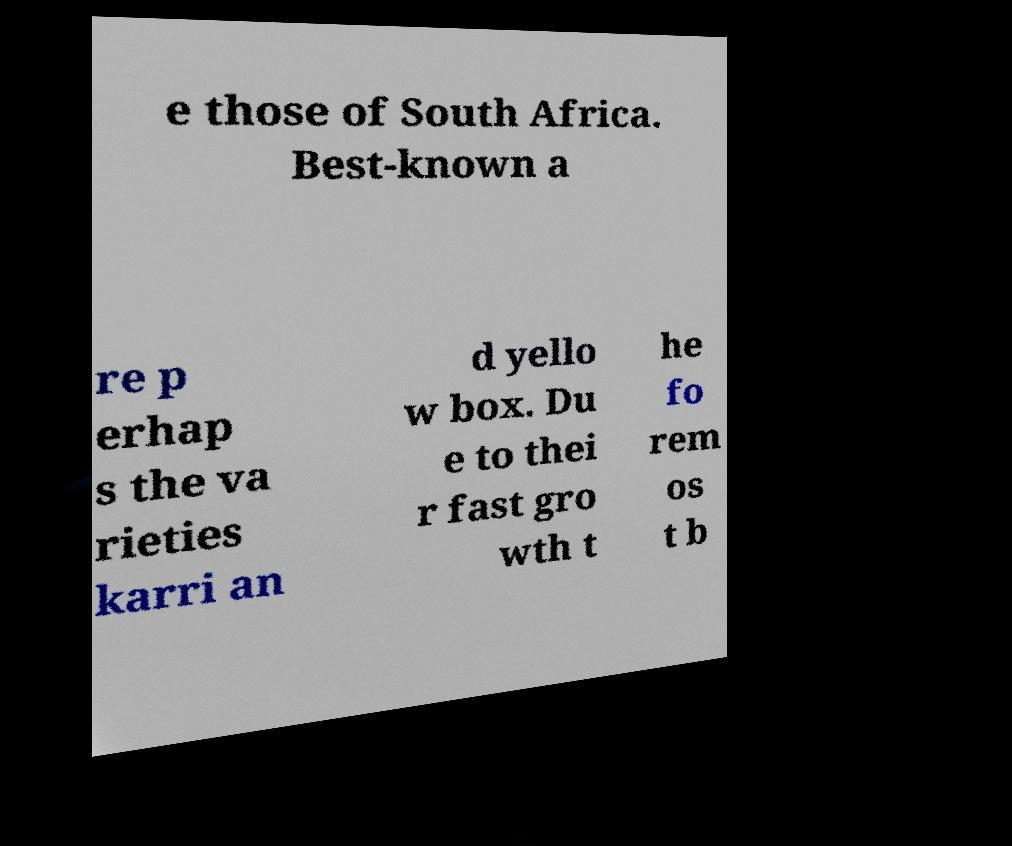Could you extract and type out the text from this image? e those of South Africa. Best-known a re p erhap s the va rieties karri an d yello w box. Du e to thei r fast gro wth t he fo rem os t b 